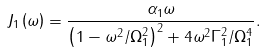<formula> <loc_0><loc_0><loc_500><loc_500>J _ { 1 } \left ( \omega \right ) = \frac { \alpha _ { 1 } \omega } { \left ( 1 - \omega ^ { 2 } / \Omega _ { 1 } ^ { 2 } \right ) ^ { 2 } + 4 \omega ^ { 2 } \Gamma _ { 1 } ^ { 2 } / \Omega _ { 1 } ^ { 4 } } .</formula> 